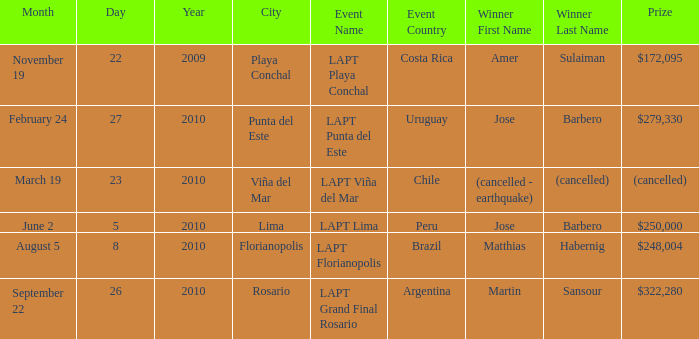Who is the champion in the city of lima? Jose Barbero. 